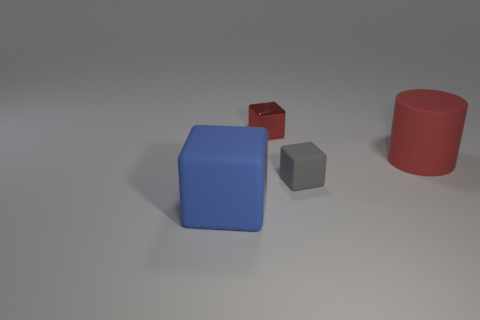Add 3 small metal objects. How many objects exist? 7 Subtract all blocks. How many objects are left? 1 Subtract 1 red cubes. How many objects are left? 3 Subtract all large purple metallic spheres. Subtract all red things. How many objects are left? 2 Add 3 large rubber cylinders. How many large rubber cylinders are left? 4 Add 1 red objects. How many red objects exist? 3 